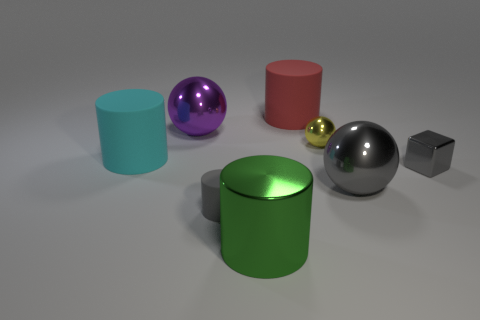If I'm looking for objects that are not spheres, which ones should I focus on? If you exclude spheres, focus on the three cylinders, which are cyan, green, and red, as well as the small grey cube found in the image. 